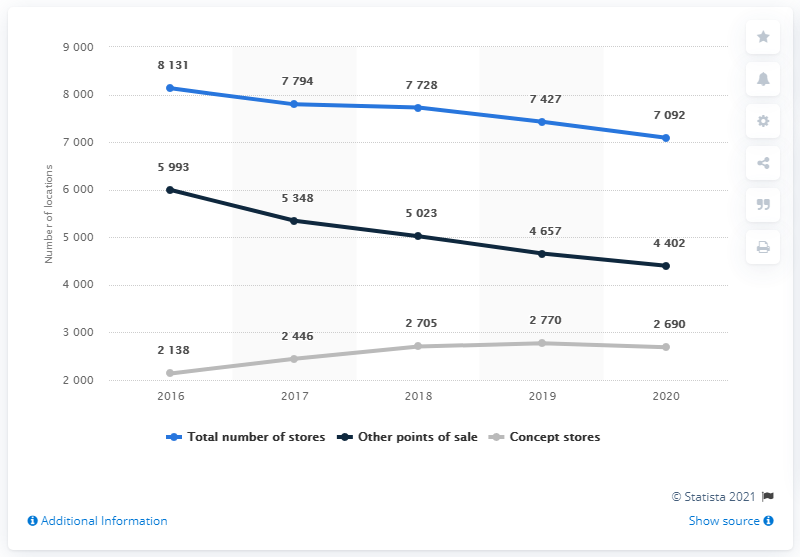Point out several critical features in this image. The median value of the data from each point of sale type was added to determine the total. In 2020, there was a decline in the gray line data. 